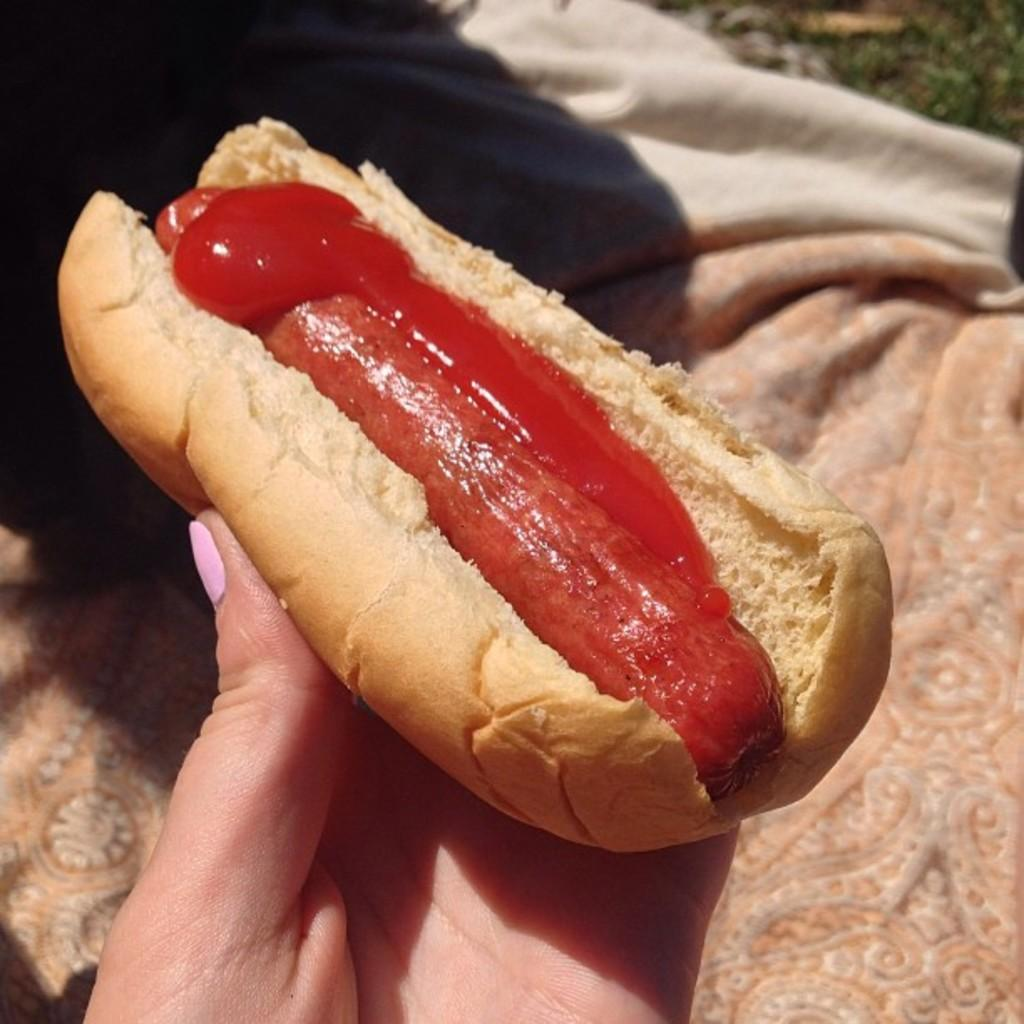What part of a person is visible in the image? There is a hand of a person in the image. What is the person holding in the image? The person is holding a hot dog. What is on the ground in the image? There is a cloth on the ground in the image. What type of spot can be seen on the person's body in the image? There is no spot visible on the person's body in the image, as only the hand is shown. What kind of battle is taking place in the image? There is no battle present in the image; it features a person holding a hot dog and a cloth on the ground. 